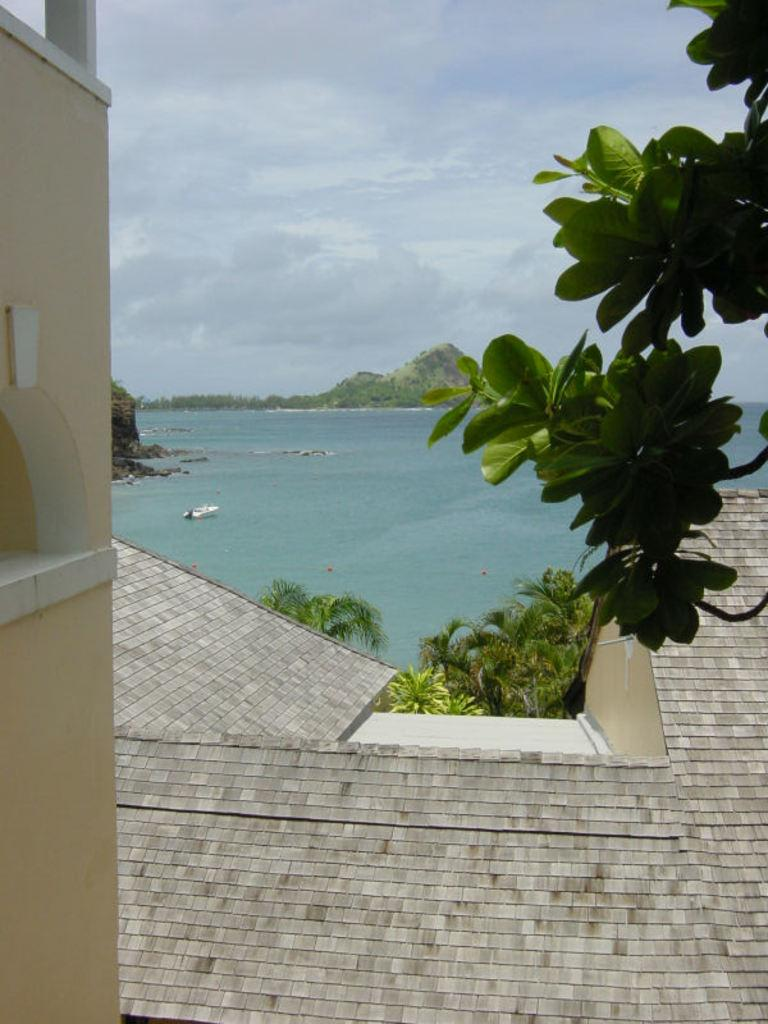What type of vegetation can be seen in the image? There are trees in the image. What type of structure is present in the image? There is a building in the image. What is covering the top of the building? There is a roof in the image. What type of landscape feature is present in the image? There is a hill in the image. What type of vehicle is present in the image? There is a boat in the image. What type of natural body is present in the image? There is sea in the image. What part of the natural environment is visible in the image? The sky is visible in the image. What type of weather can be inferred from the image? There are clouds in the sky, which suggests that it might be a partly cloudy day. What type of produce is being harvested in the middle of the image? There is no produce being harvested in the image; it features trees, a building, a roof, a hill, a boat, sea, sky, and clouds. Where is the birth of the newborn baby taking place in the image? There is no birth of a baby taking place in the image. 